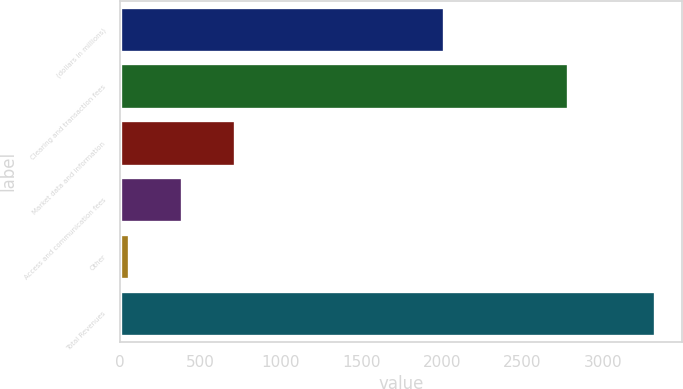Convert chart to OTSL. <chart><loc_0><loc_0><loc_500><loc_500><bar_chart><fcel>(dollars in millions)<fcel>Clearing and transaction fees<fcel>Market data and information<fcel>Access and communication fees<fcel>Other<fcel>Total Revenues<nl><fcel>2015<fcel>2783.9<fcel>711.28<fcel>384.34<fcel>57.4<fcel>3326.8<nl></chart> 